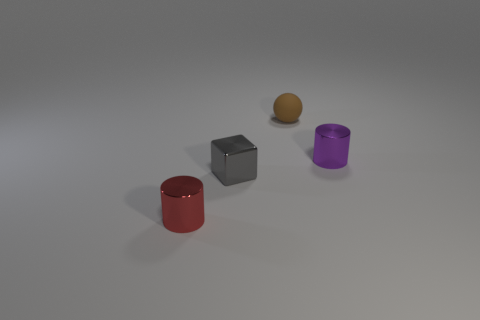What number of metal cubes have the same color as the ball?
Keep it short and to the point. 0. What number of tiny spheres have the same material as the purple thing?
Make the answer very short. 0. How many things are small balls or objects behind the tiny red metallic cylinder?
Your answer should be compact. 3. The ball right of the gray shiny cube that is in front of the metal cylinder right of the brown rubber object is what color?
Offer a terse response. Brown. How big is the metal cylinder behind the tiny red cylinder?
Your response must be concise. Small. What number of small objects are either blue metal cylinders or gray blocks?
Provide a short and direct response. 1. What is the color of the object that is behind the small gray metallic cube and on the left side of the purple cylinder?
Ensure brevity in your answer.  Brown. Are there any purple metallic objects that have the same shape as the small red object?
Provide a succinct answer. Yes. What is the small brown thing made of?
Provide a succinct answer. Rubber. Are there any objects in front of the metal cube?
Offer a very short reply. Yes. 